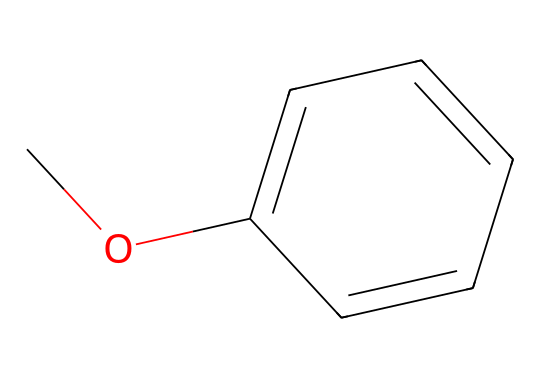What is the name of this chemical? The SMILES representation "COc1ccccc1" indicates that this compound is anisole, where 'CO' represents the methoxy group (-OCH3) attached to a benzene ring (c1ccccc1).
Answer: anisole How many carbon atoms are in anisole? In the structure, there are 8 carbon atoms: 7 from the benzene ring and 1 from the methoxy group (-OCH3).
Answer: 8 What type of functional group is present in anisole? The methoxy group (-OCH3) indicates that the functional group is an ether, as ethers contain an oxygen atom bonded to two carbon atoms.
Answer: ether What is the degree of unsaturation in anisole? Anisole has a degree of unsaturation of 4 due to the presence of one aromatic ring and no additional double bonds outside the ring. The formula gives 4 by the count of pi bonds and cycles.
Answer: 4 What is the molecular formula for anisole? By analyzing the number of atoms, we find anisole has 8 carbon, 10 hydrogen, and 1 oxygen, leading to the molecular formula C8H10O.
Answer: C8H10O Is anisole polar or nonpolar? Due to the presence of the polar methoxy group and the overall structure being influenced by the aromatic ring, anisole is considered to be slightly polar overall.
Answer: slightly polar How many hydrogen atoms are attached to the aromatic carbon atoms in anisole? The benzene ring has 5 positions available for hydrogen atoms; however, one hydrogen is replaced by the methoxy group, leaving 4 hydrogen atoms attached to the aromatic carbon.
Answer: 4 